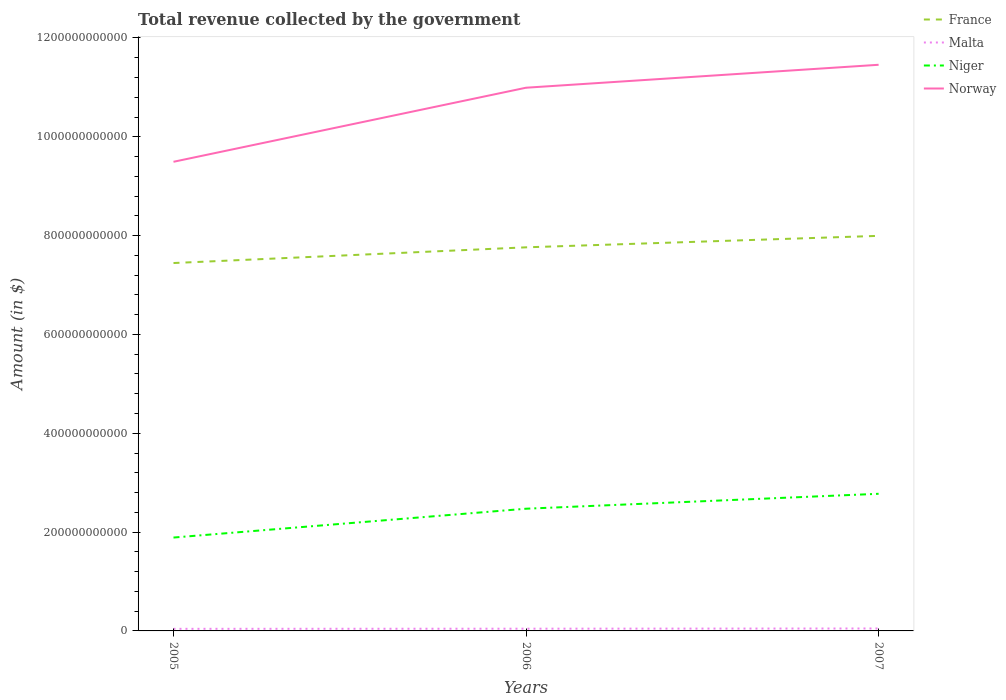Does the line corresponding to Norway intersect with the line corresponding to France?
Offer a terse response. No. Across all years, what is the maximum total revenue collected by the government in France?
Provide a short and direct response. 7.44e+11. In which year was the total revenue collected by the government in Norway maximum?
Your response must be concise. 2005. What is the total total revenue collected by the government in Norway in the graph?
Keep it short and to the point. -1.50e+11. What is the difference between the highest and the second highest total revenue collected by the government in France?
Provide a short and direct response. 5.50e+1. What is the difference between the highest and the lowest total revenue collected by the government in Niger?
Offer a terse response. 2. Is the total revenue collected by the government in Norway strictly greater than the total revenue collected by the government in France over the years?
Your response must be concise. No. How many lines are there?
Your answer should be very brief. 4. What is the difference between two consecutive major ticks on the Y-axis?
Give a very brief answer. 2.00e+11. Are the values on the major ticks of Y-axis written in scientific E-notation?
Provide a short and direct response. No. Does the graph contain any zero values?
Provide a short and direct response. No. What is the title of the graph?
Provide a succinct answer. Total revenue collected by the government. What is the label or title of the X-axis?
Keep it short and to the point. Years. What is the label or title of the Y-axis?
Provide a succinct answer. Amount (in $). What is the Amount (in $) in France in 2005?
Give a very brief answer. 7.44e+11. What is the Amount (in $) in Malta in 2005?
Your response must be concise. 4.23e+09. What is the Amount (in $) in Niger in 2005?
Provide a short and direct response. 1.89e+11. What is the Amount (in $) of Norway in 2005?
Keep it short and to the point. 9.49e+11. What is the Amount (in $) in France in 2006?
Give a very brief answer. 7.76e+11. What is the Amount (in $) of Malta in 2006?
Provide a succinct answer. 4.51e+09. What is the Amount (in $) in Niger in 2006?
Keep it short and to the point. 2.47e+11. What is the Amount (in $) of Norway in 2006?
Ensure brevity in your answer.  1.10e+12. What is the Amount (in $) of France in 2007?
Your answer should be compact. 7.99e+11. What is the Amount (in $) of Malta in 2007?
Offer a terse response. 4.93e+09. What is the Amount (in $) of Niger in 2007?
Give a very brief answer. 2.78e+11. What is the Amount (in $) of Norway in 2007?
Keep it short and to the point. 1.15e+12. Across all years, what is the maximum Amount (in $) of France?
Your answer should be very brief. 7.99e+11. Across all years, what is the maximum Amount (in $) of Malta?
Your response must be concise. 4.93e+09. Across all years, what is the maximum Amount (in $) of Niger?
Offer a very short reply. 2.78e+11. Across all years, what is the maximum Amount (in $) of Norway?
Your answer should be very brief. 1.15e+12. Across all years, what is the minimum Amount (in $) of France?
Your answer should be compact. 7.44e+11. Across all years, what is the minimum Amount (in $) in Malta?
Your answer should be very brief. 4.23e+09. Across all years, what is the minimum Amount (in $) of Niger?
Make the answer very short. 1.89e+11. Across all years, what is the minimum Amount (in $) in Norway?
Your response must be concise. 9.49e+11. What is the total Amount (in $) in France in the graph?
Give a very brief answer. 2.32e+12. What is the total Amount (in $) of Malta in the graph?
Offer a very short reply. 1.37e+1. What is the total Amount (in $) in Niger in the graph?
Make the answer very short. 7.14e+11. What is the total Amount (in $) in Norway in the graph?
Make the answer very short. 3.19e+12. What is the difference between the Amount (in $) of France in 2005 and that in 2006?
Provide a succinct answer. -3.18e+1. What is the difference between the Amount (in $) of Malta in 2005 and that in 2006?
Offer a terse response. -2.75e+08. What is the difference between the Amount (in $) of Niger in 2005 and that in 2006?
Provide a succinct answer. -5.83e+1. What is the difference between the Amount (in $) of Norway in 2005 and that in 2006?
Offer a terse response. -1.50e+11. What is the difference between the Amount (in $) of France in 2005 and that in 2007?
Make the answer very short. -5.50e+1. What is the difference between the Amount (in $) in Malta in 2005 and that in 2007?
Your answer should be compact. -7.01e+08. What is the difference between the Amount (in $) of Niger in 2005 and that in 2007?
Your response must be concise. -8.85e+1. What is the difference between the Amount (in $) of Norway in 2005 and that in 2007?
Your answer should be very brief. -1.96e+11. What is the difference between the Amount (in $) of France in 2006 and that in 2007?
Offer a terse response. -2.32e+1. What is the difference between the Amount (in $) in Malta in 2006 and that in 2007?
Your answer should be very brief. -4.26e+08. What is the difference between the Amount (in $) of Niger in 2006 and that in 2007?
Ensure brevity in your answer.  -3.02e+1. What is the difference between the Amount (in $) in Norway in 2006 and that in 2007?
Offer a terse response. -4.64e+1. What is the difference between the Amount (in $) of France in 2005 and the Amount (in $) of Malta in 2006?
Keep it short and to the point. 7.40e+11. What is the difference between the Amount (in $) in France in 2005 and the Amount (in $) in Niger in 2006?
Provide a short and direct response. 4.97e+11. What is the difference between the Amount (in $) in France in 2005 and the Amount (in $) in Norway in 2006?
Offer a terse response. -3.55e+11. What is the difference between the Amount (in $) in Malta in 2005 and the Amount (in $) in Niger in 2006?
Your answer should be very brief. -2.43e+11. What is the difference between the Amount (in $) in Malta in 2005 and the Amount (in $) in Norway in 2006?
Your answer should be very brief. -1.10e+12. What is the difference between the Amount (in $) in Niger in 2005 and the Amount (in $) in Norway in 2006?
Offer a very short reply. -9.10e+11. What is the difference between the Amount (in $) of France in 2005 and the Amount (in $) of Malta in 2007?
Provide a succinct answer. 7.40e+11. What is the difference between the Amount (in $) of France in 2005 and the Amount (in $) of Niger in 2007?
Make the answer very short. 4.67e+11. What is the difference between the Amount (in $) of France in 2005 and the Amount (in $) of Norway in 2007?
Provide a succinct answer. -4.01e+11. What is the difference between the Amount (in $) in Malta in 2005 and the Amount (in $) in Niger in 2007?
Your answer should be compact. -2.73e+11. What is the difference between the Amount (in $) of Malta in 2005 and the Amount (in $) of Norway in 2007?
Ensure brevity in your answer.  -1.14e+12. What is the difference between the Amount (in $) in Niger in 2005 and the Amount (in $) in Norway in 2007?
Your response must be concise. -9.57e+11. What is the difference between the Amount (in $) of France in 2006 and the Amount (in $) of Malta in 2007?
Ensure brevity in your answer.  7.71e+11. What is the difference between the Amount (in $) of France in 2006 and the Amount (in $) of Niger in 2007?
Your answer should be compact. 4.99e+11. What is the difference between the Amount (in $) in France in 2006 and the Amount (in $) in Norway in 2007?
Ensure brevity in your answer.  -3.69e+11. What is the difference between the Amount (in $) of Malta in 2006 and the Amount (in $) of Niger in 2007?
Your response must be concise. -2.73e+11. What is the difference between the Amount (in $) of Malta in 2006 and the Amount (in $) of Norway in 2007?
Keep it short and to the point. -1.14e+12. What is the difference between the Amount (in $) of Niger in 2006 and the Amount (in $) of Norway in 2007?
Your answer should be compact. -8.98e+11. What is the average Amount (in $) in France per year?
Keep it short and to the point. 7.73e+11. What is the average Amount (in $) in Malta per year?
Your answer should be very brief. 4.56e+09. What is the average Amount (in $) of Niger per year?
Make the answer very short. 2.38e+11. What is the average Amount (in $) of Norway per year?
Your response must be concise. 1.06e+12. In the year 2005, what is the difference between the Amount (in $) of France and Amount (in $) of Malta?
Keep it short and to the point. 7.40e+11. In the year 2005, what is the difference between the Amount (in $) in France and Amount (in $) in Niger?
Ensure brevity in your answer.  5.56e+11. In the year 2005, what is the difference between the Amount (in $) in France and Amount (in $) in Norway?
Offer a terse response. -2.05e+11. In the year 2005, what is the difference between the Amount (in $) in Malta and Amount (in $) in Niger?
Your answer should be very brief. -1.85e+11. In the year 2005, what is the difference between the Amount (in $) of Malta and Amount (in $) of Norway?
Keep it short and to the point. -9.45e+11. In the year 2005, what is the difference between the Amount (in $) of Niger and Amount (in $) of Norway?
Keep it short and to the point. -7.60e+11. In the year 2006, what is the difference between the Amount (in $) in France and Amount (in $) in Malta?
Give a very brief answer. 7.72e+11. In the year 2006, what is the difference between the Amount (in $) in France and Amount (in $) in Niger?
Give a very brief answer. 5.29e+11. In the year 2006, what is the difference between the Amount (in $) of France and Amount (in $) of Norway?
Offer a terse response. -3.23e+11. In the year 2006, what is the difference between the Amount (in $) of Malta and Amount (in $) of Niger?
Your response must be concise. -2.43e+11. In the year 2006, what is the difference between the Amount (in $) in Malta and Amount (in $) in Norway?
Offer a terse response. -1.09e+12. In the year 2006, what is the difference between the Amount (in $) in Niger and Amount (in $) in Norway?
Your answer should be compact. -8.52e+11. In the year 2007, what is the difference between the Amount (in $) in France and Amount (in $) in Malta?
Ensure brevity in your answer.  7.95e+11. In the year 2007, what is the difference between the Amount (in $) of France and Amount (in $) of Niger?
Your answer should be very brief. 5.22e+11. In the year 2007, what is the difference between the Amount (in $) of France and Amount (in $) of Norway?
Your answer should be very brief. -3.46e+11. In the year 2007, what is the difference between the Amount (in $) of Malta and Amount (in $) of Niger?
Provide a succinct answer. -2.73e+11. In the year 2007, what is the difference between the Amount (in $) of Malta and Amount (in $) of Norway?
Your answer should be compact. -1.14e+12. In the year 2007, what is the difference between the Amount (in $) in Niger and Amount (in $) in Norway?
Provide a succinct answer. -8.68e+11. What is the ratio of the Amount (in $) in Malta in 2005 to that in 2006?
Provide a succinct answer. 0.94. What is the ratio of the Amount (in $) of Niger in 2005 to that in 2006?
Make the answer very short. 0.76. What is the ratio of the Amount (in $) of Norway in 2005 to that in 2006?
Keep it short and to the point. 0.86. What is the ratio of the Amount (in $) in France in 2005 to that in 2007?
Your response must be concise. 0.93. What is the ratio of the Amount (in $) of Malta in 2005 to that in 2007?
Keep it short and to the point. 0.86. What is the ratio of the Amount (in $) in Niger in 2005 to that in 2007?
Your answer should be compact. 0.68. What is the ratio of the Amount (in $) in Norway in 2005 to that in 2007?
Provide a succinct answer. 0.83. What is the ratio of the Amount (in $) in Malta in 2006 to that in 2007?
Keep it short and to the point. 0.91. What is the ratio of the Amount (in $) in Niger in 2006 to that in 2007?
Give a very brief answer. 0.89. What is the ratio of the Amount (in $) in Norway in 2006 to that in 2007?
Offer a very short reply. 0.96. What is the difference between the highest and the second highest Amount (in $) of France?
Your response must be concise. 2.32e+1. What is the difference between the highest and the second highest Amount (in $) of Malta?
Provide a succinct answer. 4.26e+08. What is the difference between the highest and the second highest Amount (in $) in Niger?
Give a very brief answer. 3.02e+1. What is the difference between the highest and the second highest Amount (in $) of Norway?
Provide a short and direct response. 4.64e+1. What is the difference between the highest and the lowest Amount (in $) in France?
Make the answer very short. 5.50e+1. What is the difference between the highest and the lowest Amount (in $) in Malta?
Provide a succinct answer. 7.01e+08. What is the difference between the highest and the lowest Amount (in $) in Niger?
Your answer should be compact. 8.85e+1. What is the difference between the highest and the lowest Amount (in $) of Norway?
Your answer should be compact. 1.96e+11. 